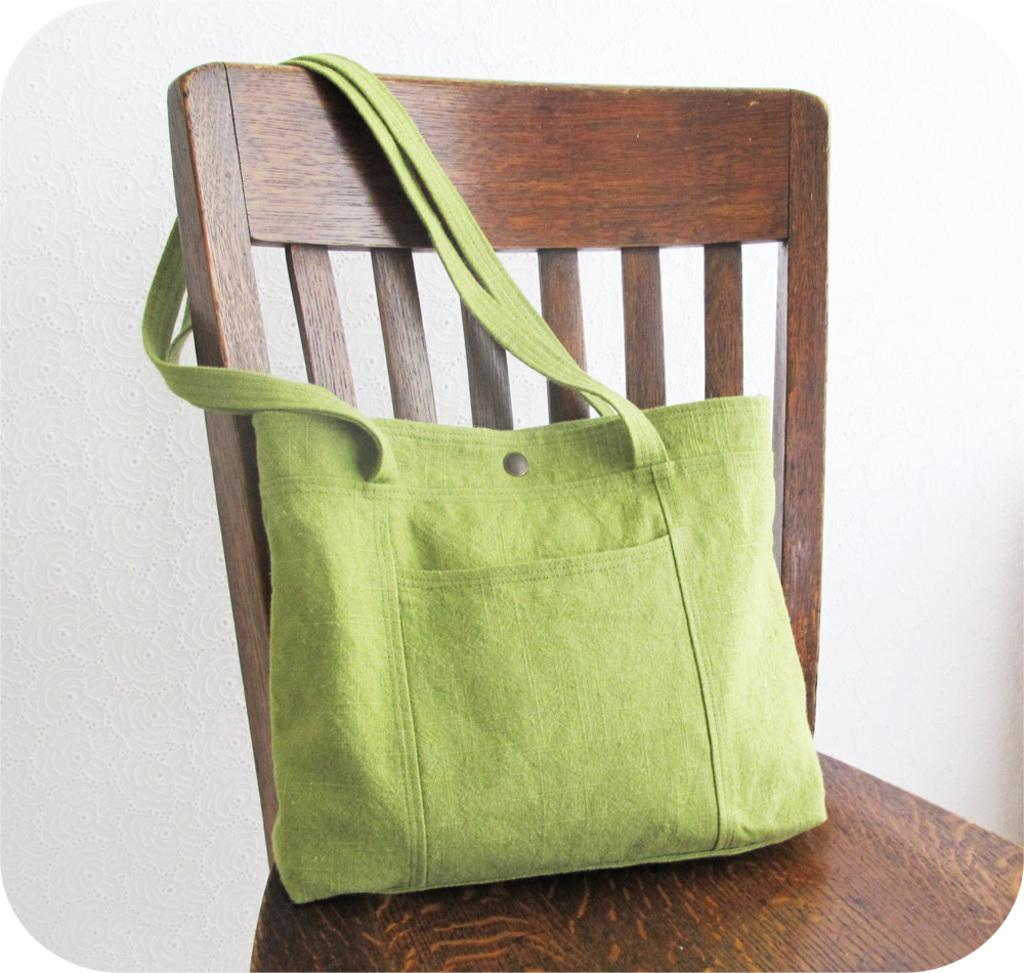What is the color of the bag in the image? The bag in the image is green. How is the bag positioned in the image? The bag is hanged on a chair. How many boys are sitting on the chair with the green bag in the image? There is no reference to any boys in the image; it only features a green color bag hanged on a chair. What type of sack can be seen being used as a footrest in the image? There is no sack present in the image, nor is there any indication of a footrest. 